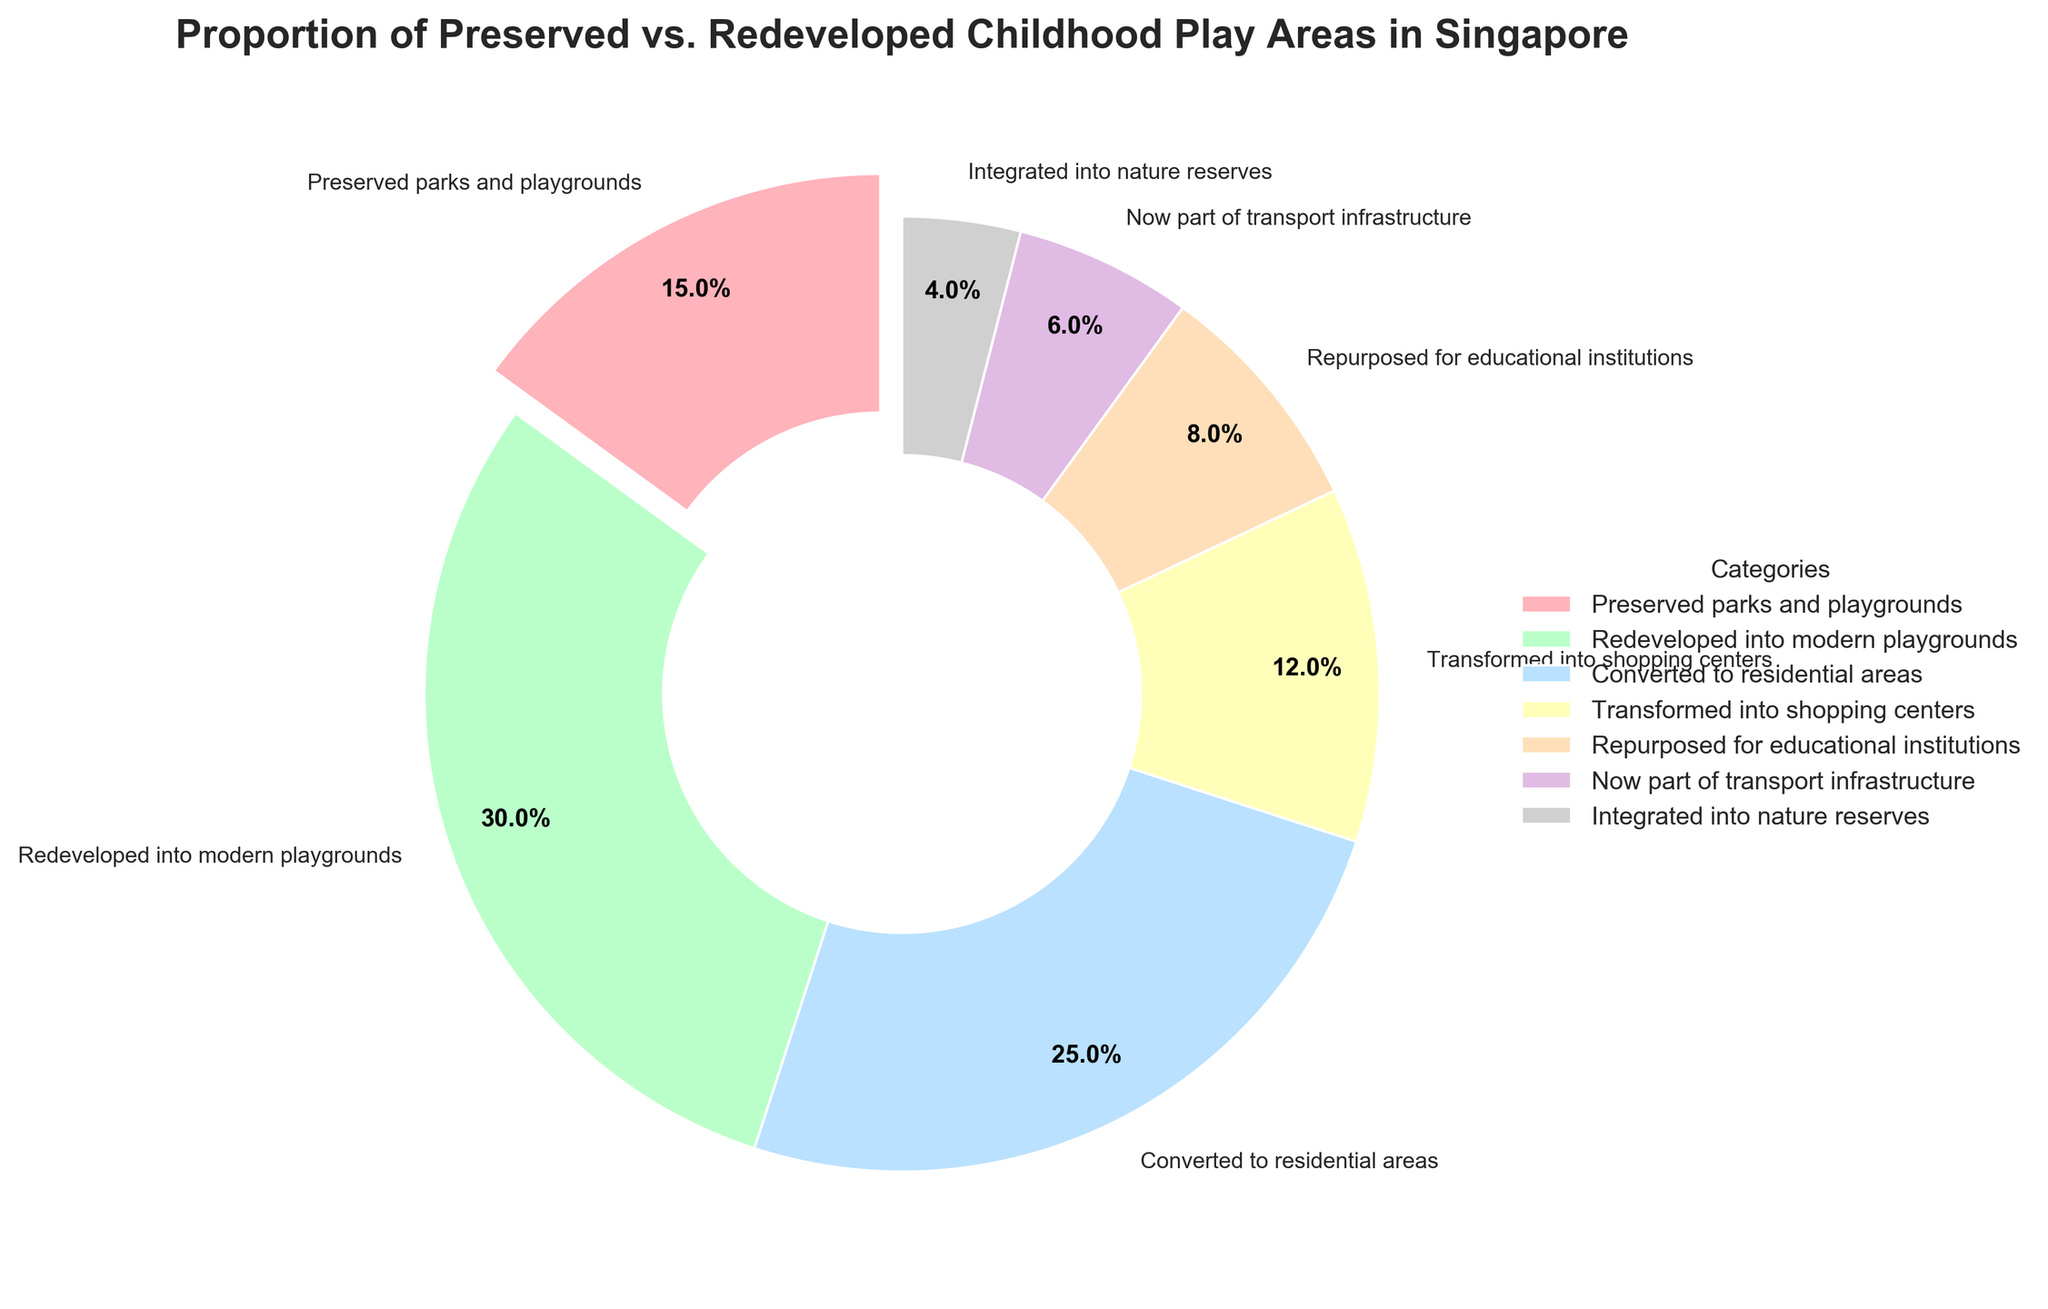What proportion of childhood play areas were either transformed into shopping centers or converted to residential areas? Combine the percentages of play areas transformed into shopping centers (12%) and those converted to residential areas (25%). 12% + 25% = 37%.
Answer: 37% Which category has the smallest proportion of childhood play areas? By observing the figure, the category with the smallest slice is integrated into nature reserves, which is 4%.
Answer: Integrated into nature reserves Are there more childhood play areas preserved or redeveloped into residential areas? Compare the percentages of preserved parks and playgrounds (15%) and those converted to residential areas (25%). 25% > 15%, so more play areas were redeveloped into residential areas.
Answer: Redeveloped into residential areas What is the combined percentage of childhood play areas that are currently used for transport infrastructure or educational institutions? Combine the percentages from the categories now part of transport infrastructure (6%) and repurposed for educational institutions (8%). 6% + 8% = 14%.
Answer: 14% By how much does the proportion of redeveloped modern playgrounds exceed that of preserved parks and playgrounds? Subtract the percentage of preserved parks and playgrounds (15%) from the percentage of redeveloped modern playgrounds (30%). 30% - 15% = 15%.
Answer: 15% Which use of childhood play areas constitutes the largest proportion? By observing the figure, the category with the largest slice is redeveloped into modern playgrounds, which is 30%.
Answer: Redeveloped into modern playgrounds Is the proportion of childhood play areas transformed into shopping centers larger than those integrated into nature reserves? Compare the percentages of play areas transformed into shopping centers (12%) and those integrated into nature reserves (4%). 12% > 4%, so yes.
Answer: Yes How do the proportions of preserved parks and playgrounds compare to those repurposed for educational institutions? Compare the percentages of preserved parks and playgrounds (15%) and those repurposed for educational institutions (8%). 15% > 8%, so preserved parks and playgrounds constitute a larger proportion.
Answer: Preserved parks and playgrounds What percentage of childhood play areas remain unchanged? The percentage of preserved parks and playgrounds is 15%.
Answer: 15% How many categories have a proportion less than 10%? By observing the figure, these categories are repurposed for educational institutions (8%), now part of transport infrastructure (6%), and integrated into nature reserves (4%). So, 3 categories.
Answer: 3 